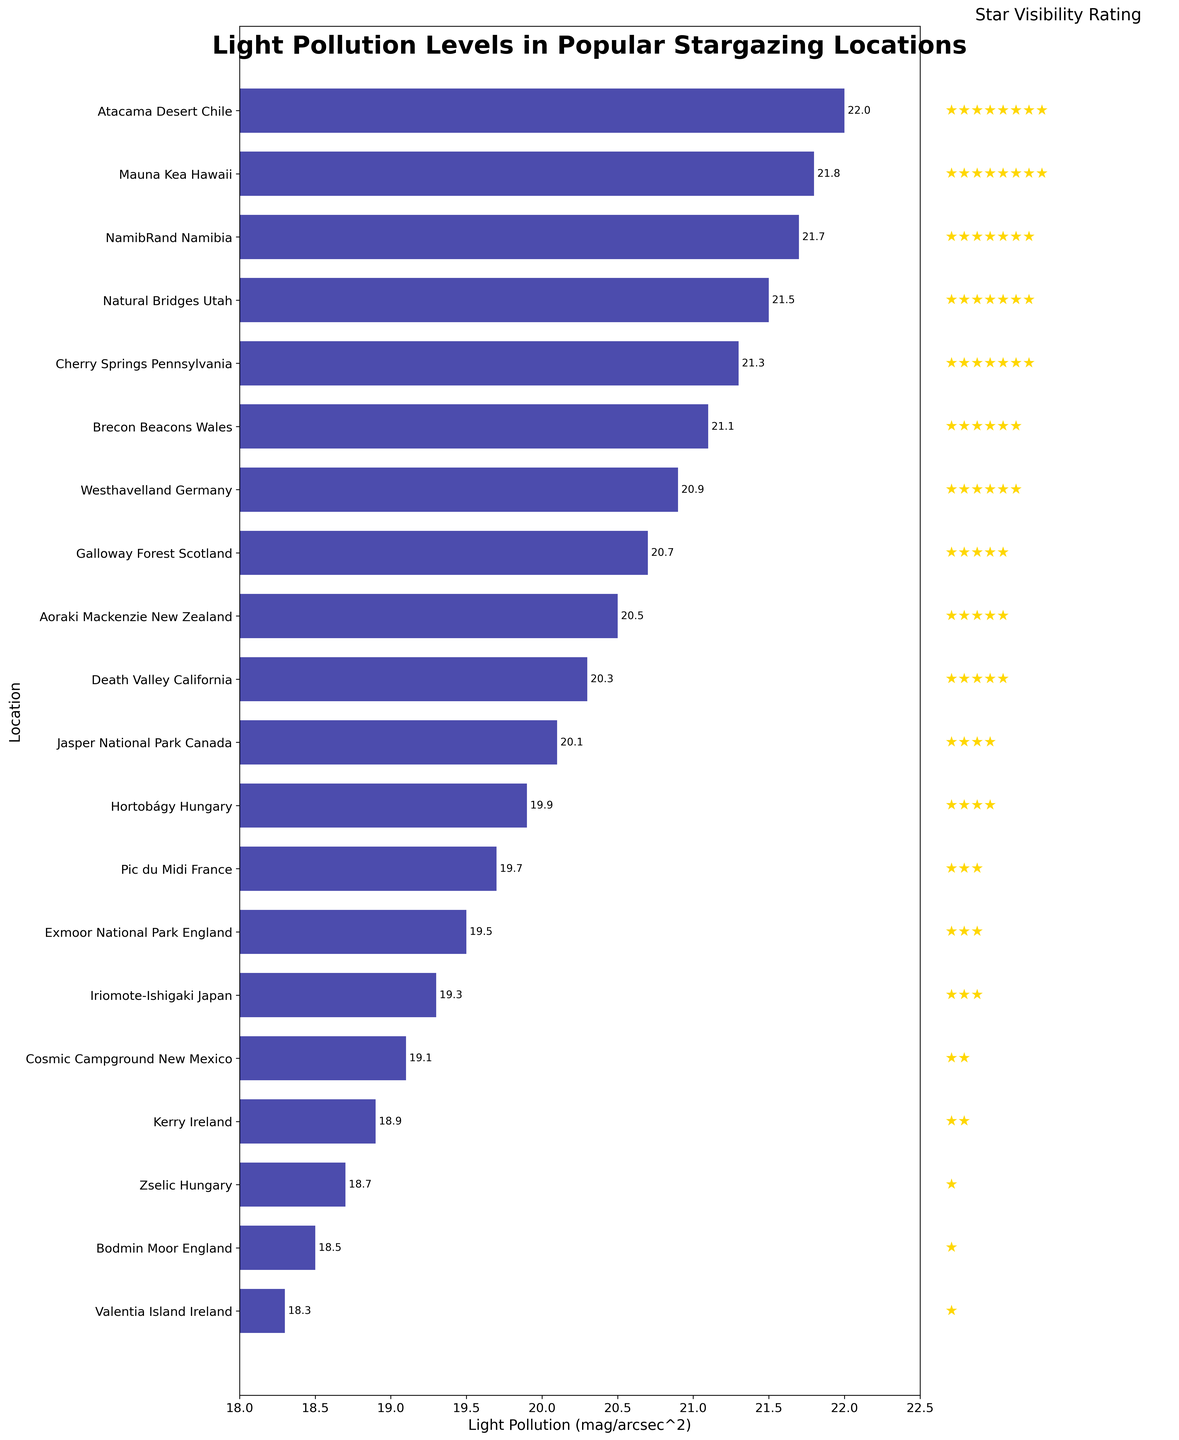Which location has the highest light pollution level? Look for the location at the top of the horizontal bar chart which indicates the highest value on the x-axis. That is Iriomote-Ishigaki, Japan with a level of 19.3 mag/arcsec^2.
Answer: Iriomote-Ishigaki, Japan Which location has the lowest light pollution level? Look for the location at the bottom of the horizontal bar chart which indicates the lowest value on the x-axis. That is Atacama Desert, Chile with a level of 22.0 mag/arcsec^2.
Answer: Atacama Desert, Chile What is the difference in light pollution levels between Natural Bridges, Utah and Cherry Springs, Pennsylvania? First, find the light pollution levels of both locations from the chart: Natural Bridges, Utah has 21.5 mag/arcsec^2 and Cherry Springs, Pennsylvania has 21.3 mag/arcsec^2. Then subtract the two values: 21.5 - 21.3 = 0.2.
Answer: 0.2 mag/arcsec^2 What is the average light pollution level of the top 3 locations with the lowest light pollution? Identify the top 3 locations from the chart: Atacama Desert, Chile (22.0), Mauna Kea, Hawaii (21.8), and NamibRand, Namibia (21.7). Sum these values: 22.0 + 21.8 + 21.7 = 65.5. Then divide by 3: 65.5 / 3 = 21.833.
Answer: 21.833 mag/arcsec^2 Which location has a better star visibility rating, Brecon Beacons, Wales or Galloway Forest, Scotland? Compare the star ratings shown on the right subplot. Brecon Beacons, Wales has more stars (4) compared to Galloway Forest, Scotland (3). Therefore, Brecon Beacons has a better rating.
Answer: Brecon Beacons, Wales What is the light pollution level range across all locations in the chart? Identify the minimum and maximum levels: lowest is 18.3 (Valentia Island, Ireland) and the highest is 22.0 (Atacama Desert, Chile). Subtract the lowest from the highest: 22.0 - 18.3 = 3.7.
Answer: 3.7 mag/arcsec^2 How many locations have a light pollution level less than 20 mag/arcsec^2? Count all the bars in the horizontal bar chart that are to the left of the 20 mag/arcsec^2 mark. These are 8 locations.
Answer: 8 locations What is the median light pollution level of these locations? Since there are 20 locations, the median will be the average of the 10th and 11th values when sorted. These values are Death Valley, California (20.3) and Jasper National Park, Canada (20.1). The median is (20.3+20.1)/2 = 20.2.
Answer: 20.2 mag/arcsec^2 Which location has a light pollution level closest to the average light pollution level? First, calculate the average light pollution level of all locations. Sum all values: (22.0 + 21.8 + 21.7 + 21.5 + 21.3 + 21.1 + 20.9 + 20.7 + 20.5 + 20.3 + 20.1 + 19.9 + 19.7 + 19.5 + 19.3 + 19.1 + 18.9 + 18.7 + 18.5 + 18.3) / 20 = 20.1. The location closest to 20.1 is Jasper National Park, Canada with an exact value of 20.1.
Answer: Jasper National Park, Canada 